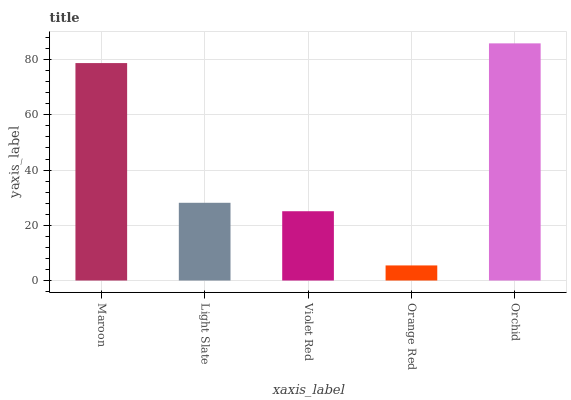Is Orange Red the minimum?
Answer yes or no. Yes. Is Orchid the maximum?
Answer yes or no. Yes. Is Light Slate the minimum?
Answer yes or no. No. Is Light Slate the maximum?
Answer yes or no. No. Is Maroon greater than Light Slate?
Answer yes or no. Yes. Is Light Slate less than Maroon?
Answer yes or no. Yes. Is Light Slate greater than Maroon?
Answer yes or no. No. Is Maroon less than Light Slate?
Answer yes or no. No. Is Light Slate the high median?
Answer yes or no. Yes. Is Light Slate the low median?
Answer yes or no. Yes. Is Orange Red the high median?
Answer yes or no. No. Is Orchid the low median?
Answer yes or no. No. 